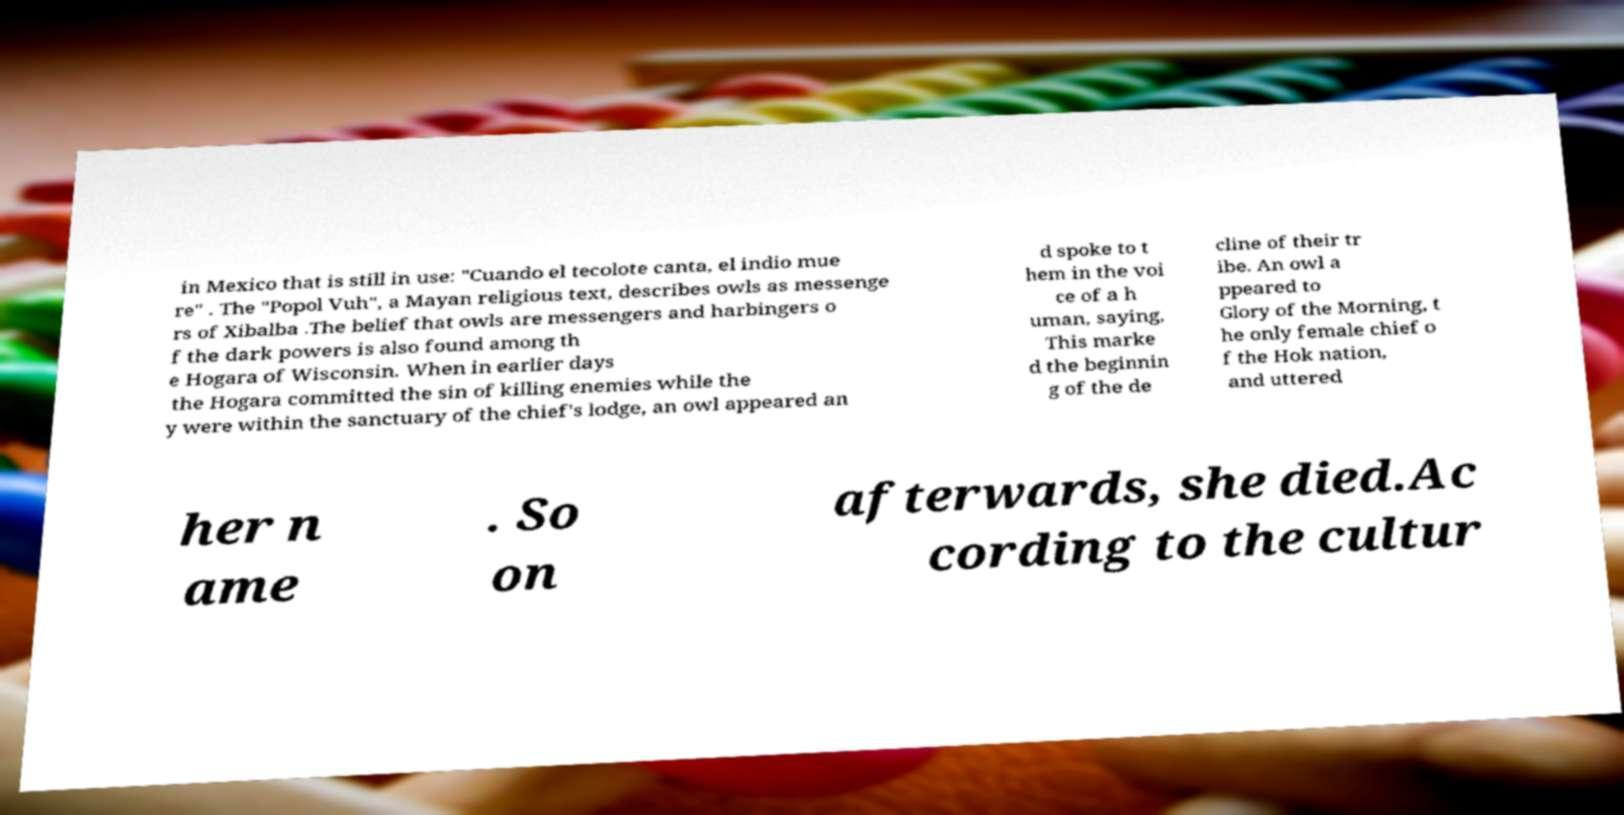Please read and relay the text visible in this image. What does it say? in Mexico that is still in use: "Cuando el tecolote canta, el indio mue re" . The "Popol Vuh", a Mayan religious text, describes owls as messenge rs of Xibalba .The belief that owls are messengers and harbingers o f the dark powers is also found among th e Hogara of Wisconsin. When in earlier days the Hogara committed the sin of killing enemies while the y were within the sanctuary of the chief's lodge, an owl appeared an d spoke to t hem in the voi ce of a h uman, saying, This marke d the beginnin g of the de cline of their tr ibe. An owl a ppeared to Glory of the Morning, t he only female chief o f the Hok nation, and uttered her n ame . So on afterwards, she died.Ac cording to the cultur 